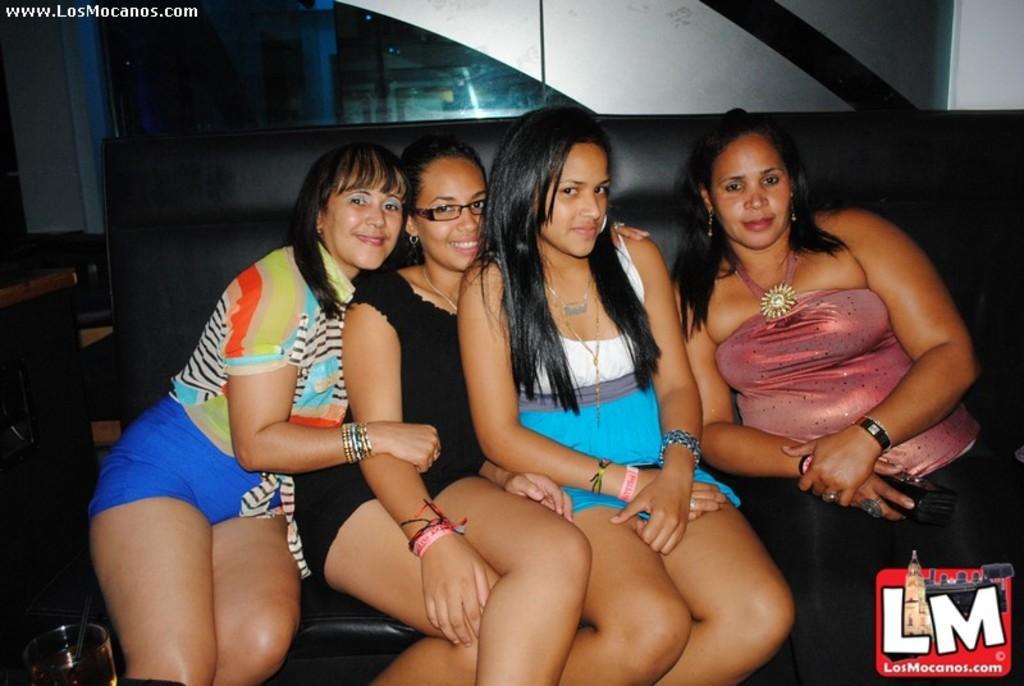Please provide a concise description of this image. In this image there are four women sitting on a sofa, on the bottom left there is a glass, on the top left there is text, in the background there is a wall, for that wall there is glass, on the bottom right there is a logo. 